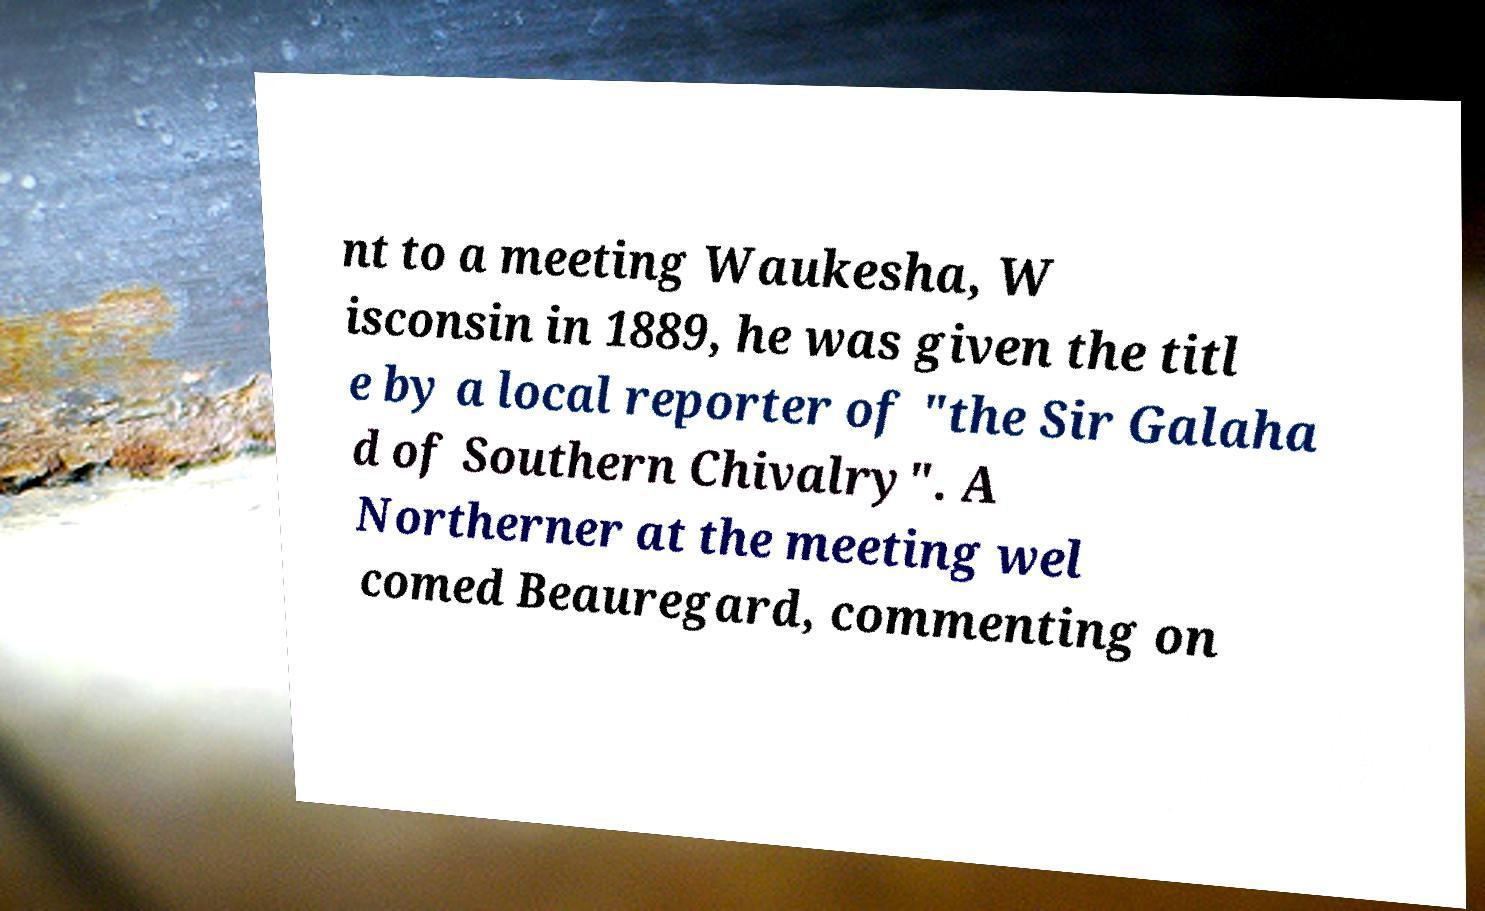Please identify and transcribe the text found in this image. nt to a meeting Waukesha, W isconsin in 1889, he was given the titl e by a local reporter of "the Sir Galaha d of Southern Chivalry". A Northerner at the meeting wel comed Beauregard, commenting on 